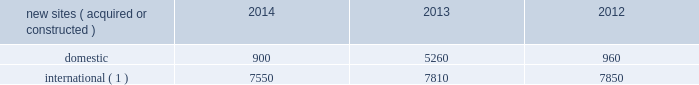Rental and management operations new site revenue growth .
During the year ended december 31 , 2014 , we grew our portfolio of communications real estate through the acquisition and construction of approximately 8450 sites .
In a majority of our international markets , the acquisition or construction of new sites results in increased pass-through revenues ( such as ground rent or power and fuel costs ) and expenses .
We continue to evaluate opportunities to acquire communications real estate portfolios , both domestically and internationally , to determine whether they meet our risk-adjusted hurdle rates and whether we believe we can effectively integrate them into our existing portfolio. .
( 1 ) the majority of sites acquired or constructed in 2014 were in brazil , india and mexico ; in 2013 were in brazil , colombia , costa rica , india , mexico and south africa ; and in 2012 were in brazil , germany , india and uganda .
Rental and management operations expenses .
Direct operating expenses incurred by our domestic and international rental and management segments include direct site level expenses and consist primarily of ground rent and power and fuel costs , some of which may be passed through to our tenants , as well as property taxes , repairs and maintenance .
These segment direct operating expenses exclude all segment and corporate selling , general , administrative and development expenses , which are aggregated into one line item entitled selling , general , administrative and development expense in our consolidated statements of operations .
In general , our domestic and international rental and management segments 2019 selling , general , administrative and development expenses do not significantly increase as a result of adding incremental tenants to our legacy sites and typically increase only modestly year-over-year .
As a result , leasing additional space to new tenants on our legacy sites provides significant incremental cash flow .
We may , however , incur additional segment selling , general , administrative and development expenses as we increase our presence in geographic areas where we have recently launched operations or are focused on expanding our portfolio .
Our profit margin growth is therefore positively impacted by the addition of new tenants to our legacy sites and can be temporarily diluted by our development activities .
Network development services segment revenue growth .
As we continue to focus on growing our rental and management operations , we anticipate that our network development services revenue will continue to represent a small percentage of our total revenues .
Non-gaap financial measures included in our analysis of our results of operations are discussions regarding earnings before interest , taxes , depreciation , amortization and accretion , as adjusted ( 201cadjusted ebitda 201d ) , funds from operations , as defined by the national association of real estate investment trusts ( 201cnareit ffo 201d ) and adjusted funds from operations ( 201caffo 201d ) .
We define adjusted ebitda as net income before income ( loss ) on discontinued operations , net ; income ( loss ) on equity method investments ; income tax benefit ( provision ) ; other income ( expense ) ; gain ( loss ) on retirement of long-term obligations ; interest expense ; interest income ; other operating income ( expense ) ; depreciation , amortization and accretion ; and stock-based compensation expense .
Nareit ffo is defined as net income before gains or losses from the sale or disposal of real estate , real estate related impairment charges , real estate related depreciation , amortization and accretion and dividends declared on preferred stock , and including adjustments for ( i ) unconsolidated affiliates and ( ii ) noncontrolling interest. .
How many new sites were in the us during 2012 to 2014?\\n? 
Computations: table_sum(domestic, none)
Answer: 7120.0. 